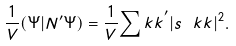<formula> <loc_0><loc_0><loc_500><loc_500>\frac { 1 } { V } ( \Psi | N ^ { \prime } \Psi ) = \frac { 1 } { V } { \sum _ { \ } k k } ^ { \prime } | s _ { \ } k k | ^ { 2 } .</formula> 